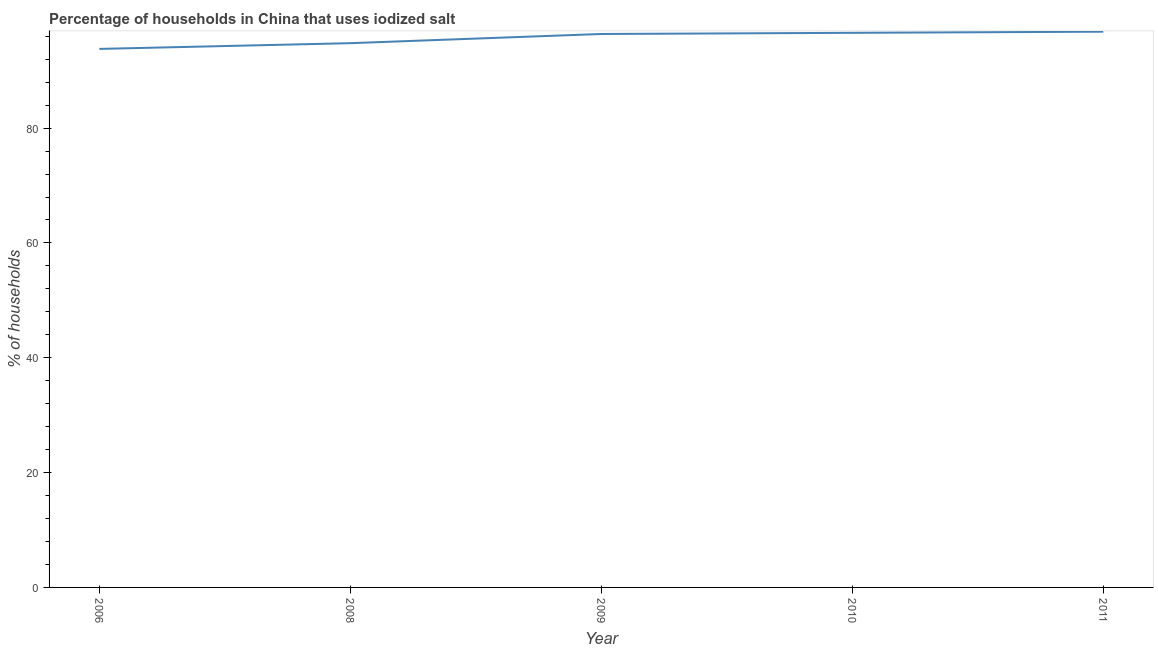What is the percentage of households where iodized salt is consumed in 2010?
Provide a succinct answer. 96.6. Across all years, what is the maximum percentage of households where iodized salt is consumed?
Your answer should be very brief. 96.8. Across all years, what is the minimum percentage of households where iodized salt is consumed?
Ensure brevity in your answer.  93.8. In which year was the percentage of households where iodized salt is consumed minimum?
Offer a very short reply. 2006. What is the sum of the percentage of households where iodized salt is consumed?
Your answer should be very brief. 478.4. What is the difference between the percentage of households where iodized salt is consumed in 2008 and 2009?
Your answer should be compact. -1.6. What is the average percentage of households where iodized salt is consumed per year?
Provide a short and direct response. 95.68. What is the median percentage of households where iodized salt is consumed?
Your answer should be very brief. 96.4. In how many years, is the percentage of households where iodized salt is consumed greater than 8 %?
Offer a terse response. 5. Do a majority of the years between 2010 and 2006 (inclusive) have percentage of households where iodized salt is consumed greater than 60 %?
Offer a very short reply. Yes. What is the ratio of the percentage of households where iodized salt is consumed in 2010 to that in 2011?
Give a very brief answer. 1. Is the percentage of households where iodized salt is consumed in 2008 less than that in 2009?
Your response must be concise. Yes. What is the difference between the highest and the second highest percentage of households where iodized salt is consumed?
Keep it short and to the point. 0.2. In how many years, is the percentage of households where iodized salt is consumed greater than the average percentage of households where iodized salt is consumed taken over all years?
Your response must be concise. 3. How many lines are there?
Offer a terse response. 1. Are the values on the major ticks of Y-axis written in scientific E-notation?
Keep it short and to the point. No. Does the graph contain grids?
Give a very brief answer. No. What is the title of the graph?
Provide a succinct answer. Percentage of households in China that uses iodized salt. What is the label or title of the X-axis?
Ensure brevity in your answer.  Year. What is the label or title of the Y-axis?
Give a very brief answer. % of households. What is the % of households of 2006?
Provide a succinct answer. 93.8. What is the % of households of 2008?
Your answer should be very brief. 94.8. What is the % of households in 2009?
Give a very brief answer. 96.4. What is the % of households of 2010?
Make the answer very short. 96.6. What is the % of households of 2011?
Your response must be concise. 96.8. What is the difference between the % of households in 2006 and 2008?
Offer a very short reply. -1. What is the difference between the % of households in 2006 and 2009?
Offer a terse response. -2.6. What is the difference between the % of households in 2006 and 2010?
Offer a very short reply. -2.8. What is the difference between the % of households in 2008 and 2009?
Your answer should be very brief. -1.6. What is the difference between the % of households in 2009 and 2011?
Your answer should be very brief. -0.4. What is the difference between the % of households in 2010 and 2011?
Make the answer very short. -0.2. What is the ratio of the % of households in 2006 to that in 2009?
Your answer should be very brief. 0.97. What is the ratio of the % of households in 2006 to that in 2010?
Your response must be concise. 0.97. What is the ratio of the % of households in 2010 to that in 2011?
Your answer should be very brief. 1. 